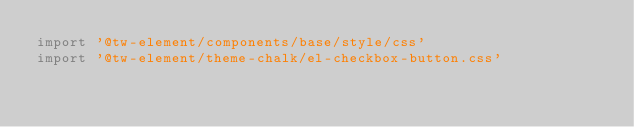Convert code to text. <code><loc_0><loc_0><loc_500><loc_500><_TypeScript_>import '@tw-element/components/base/style/css'
import '@tw-element/theme-chalk/el-checkbox-button.css'
</code> 